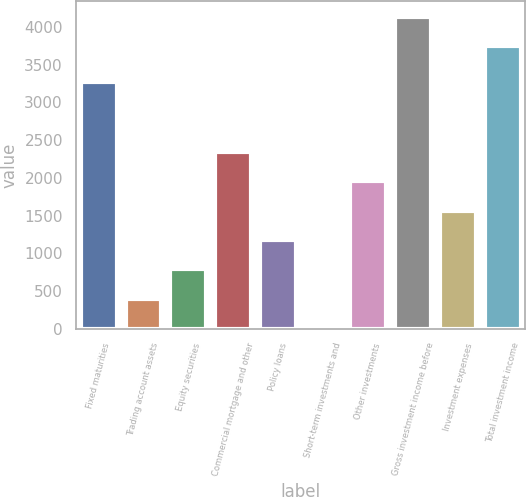Convert chart. <chart><loc_0><loc_0><loc_500><loc_500><bar_chart><fcel>Fixed maturities<fcel>Trading account assets<fcel>Equity securities<fcel>Commercial mortgage and other<fcel>Policy loans<fcel>Short-term investments and<fcel>Other investments<fcel>Gross investment income before<fcel>Investment expenses<fcel>Total investment income<nl><fcel>3269<fcel>394.1<fcel>784.2<fcel>2344.6<fcel>1174.3<fcel>4<fcel>1954.5<fcel>4139.1<fcel>1564.4<fcel>3749<nl></chart> 